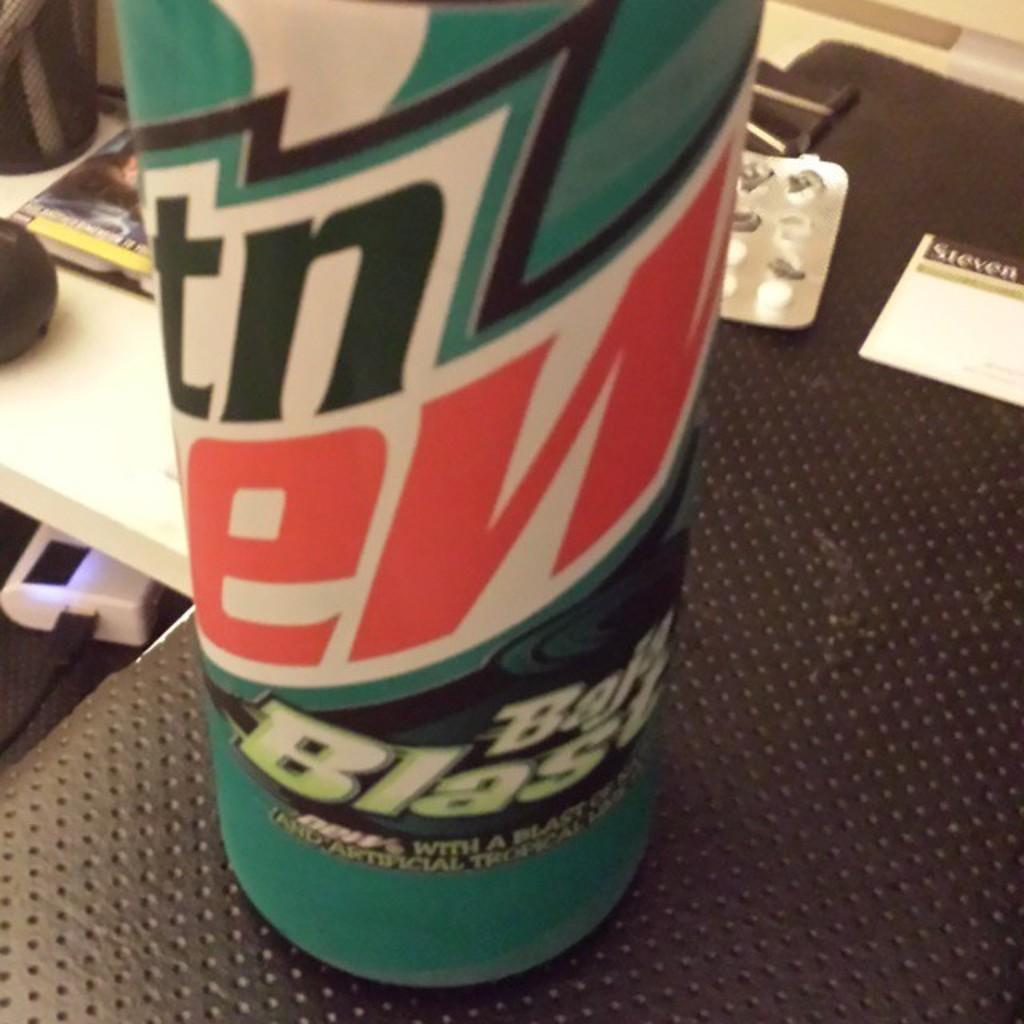<image>
Share a concise interpretation of the image provided. A Bala Blasa soda can sitting on a black shelf next to paper. 